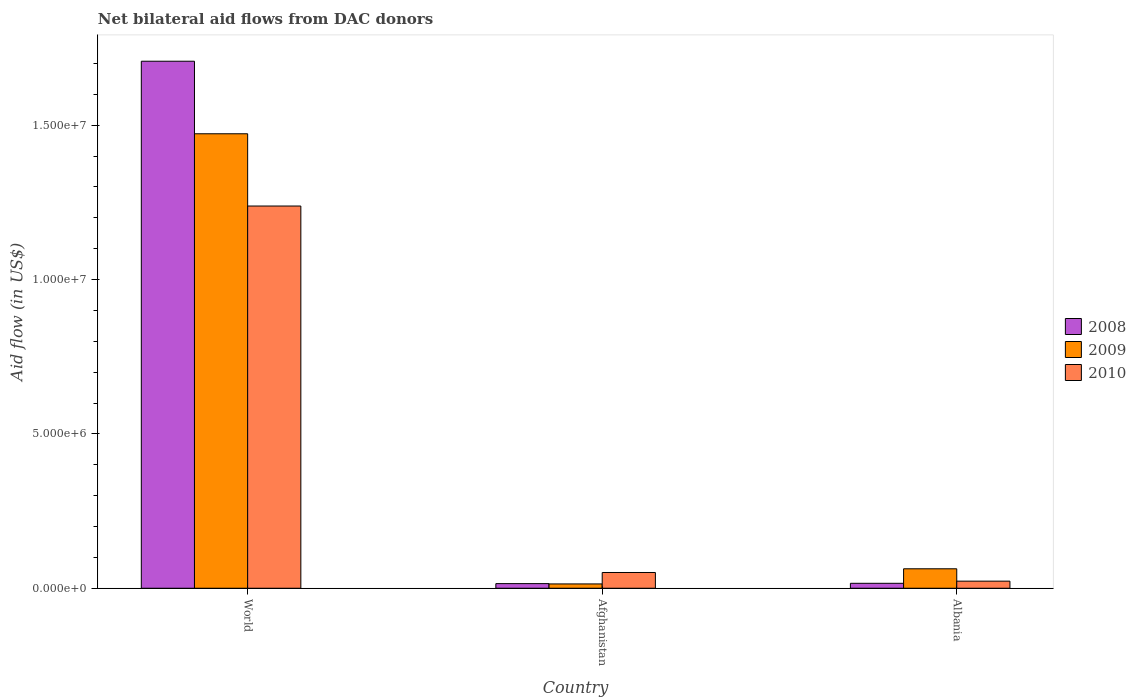How many groups of bars are there?
Ensure brevity in your answer.  3. How many bars are there on the 1st tick from the left?
Make the answer very short. 3. What is the label of the 3rd group of bars from the left?
Make the answer very short. Albania. What is the net bilateral aid flow in 2009 in World?
Provide a succinct answer. 1.47e+07. Across all countries, what is the maximum net bilateral aid flow in 2009?
Provide a short and direct response. 1.47e+07. In which country was the net bilateral aid flow in 2010 minimum?
Make the answer very short. Albania. What is the total net bilateral aid flow in 2009 in the graph?
Your answer should be very brief. 1.55e+07. What is the difference between the net bilateral aid flow in 2009 in Afghanistan and that in World?
Provide a succinct answer. -1.46e+07. What is the difference between the net bilateral aid flow in 2010 in World and the net bilateral aid flow in 2008 in Afghanistan?
Your answer should be compact. 1.22e+07. What is the average net bilateral aid flow in 2009 per country?
Provide a succinct answer. 5.16e+06. What is the difference between the net bilateral aid flow of/in 2009 and net bilateral aid flow of/in 2010 in Afghanistan?
Offer a terse response. -3.70e+05. What is the ratio of the net bilateral aid flow in 2009 in Albania to that in World?
Give a very brief answer. 0.04. What is the difference between the highest and the second highest net bilateral aid flow in 2008?
Your answer should be very brief. 1.69e+07. What is the difference between the highest and the lowest net bilateral aid flow in 2010?
Your answer should be very brief. 1.22e+07. In how many countries, is the net bilateral aid flow in 2010 greater than the average net bilateral aid flow in 2010 taken over all countries?
Your response must be concise. 1. Is the sum of the net bilateral aid flow in 2010 in Afghanistan and World greater than the maximum net bilateral aid flow in 2008 across all countries?
Give a very brief answer. No. What does the 2nd bar from the left in Afghanistan represents?
Ensure brevity in your answer.  2009. How many bars are there?
Ensure brevity in your answer.  9. How many countries are there in the graph?
Keep it short and to the point. 3. What is the difference between two consecutive major ticks on the Y-axis?
Provide a succinct answer. 5.00e+06. Does the graph contain grids?
Ensure brevity in your answer.  No. Where does the legend appear in the graph?
Your answer should be compact. Center right. What is the title of the graph?
Provide a succinct answer. Net bilateral aid flows from DAC donors. What is the label or title of the X-axis?
Provide a succinct answer. Country. What is the label or title of the Y-axis?
Give a very brief answer. Aid flow (in US$). What is the Aid flow (in US$) of 2008 in World?
Make the answer very short. 1.71e+07. What is the Aid flow (in US$) in 2009 in World?
Offer a terse response. 1.47e+07. What is the Aid flow (in US$) in 2010 in World?
Offer a terse response. 1.24e+07. What is the Aid flow (in US$) in 2009 in Afghanistan?
Make the answer very short. 1.40e+05. What is the Aid flow (in US$) of 2010 in Afghanistan?
Your response must be concise. 5.10e+05. What is the Aid flow (in US$) in 2009 in Albania?
Offer a terse response. 6.30e+05. Across all countries, what is the maximum Aid flow (in US$) of 2008?
Keep it short and to the point. 1.71e+07. Across all countries, what is the maximum Aid flow (in US$) in 2009?
Your response must be concise. 1.47e+07. Across all countries, what is the maximum Aid flow (in US$) of 2010?
Offer a very short reply. 1.24e+07. Across all countries, what is the minimum Aid flow (in US$) of 2009?
Offer a terse response. 1.40e+05. What is the total Aid flow (in US$) of 2008 in the graph?
Keep it short and to the point. 1.74e+07. What is the total Aid flow (in US$) in 2009 in the graph?
Keep it short and to the point. 1.55e+07. What is the total Aid flow (in US$) in 2010 in the graph?
Provide a succinct answer. 1.31e+07. What is the difference between the Aid flow (in US$) in 2008 in World and that in Afghanistan?
Your answer should be compact. 1.69e+07. What is the difference between the Aid flow (in US$) of 2009 in World and that in Afghanistan?
Provide a short and direct response. 1.46e+07. What is the difference between the Aid flow (in US$) in 2010 in World and that in Afghanistan?
Keep it short and to the point. 1.19e+07. What is the difference between the Aid flow (in US$) in 2008 in World and that in Albania?
Ensure brevity in your answer.  1.69e+07. What is the difference between the Aid flow (in US$) of 2009 in World and that in Albania?
Give a very brief answer. 1.41e+07. What is the difference between the Aid flow (in US$) of 2010 in World and that in Albania?
Offer a terse response. 1.22e+07. What is the difference between the Aid flow (in US$) in 2009 in Afghanistan and that in Albania?
Your answer should be very brief. -4.90e+05. What is the difference between the Aid flow (in US$) in 2010 in Afghanistan and that in Albania?
Your answer should be compact. 2.80e+05. What is the difference between the Aid flow (in US$) in 2008 in World and the Aid flow (in US$) in 2009 in Afghanistan?
Your answer should be very brief. 1.69e+07. What is the difference between the Aid flow (in US$) in 2008 in World and the Aid flow (in US$) in 2010 in Afghanistan?
Your response must be concise. 1.66e+07. What is the difference between the Aid flow (in US$) in 2009 in World and the Aid flow (in US$) in 2010 in Afghanistan?
Provide a succinct answer. 1.42e+07. What is the difference between the Aid flow (in US$) of 2008 in World and the Aid flow (in US$) of 2009 in Albania?
Offer a very short reply. 1.64e+07. What is the difference between the Aid flow (in US$) of 2008 in World and the Aid flow (in US$) of 2010 in Albania?
Your response must be concise. 1.68e+07. What is the difference between the Aid flow (in US$) in 2009 in World and the Aid flow (in US$) in 2010 in Albania?
Offer a terse response. 1.45e+07. What is the difference between the Aid flow (in US$) in 2008 in Afghanistan and the Aid flow (in US$) in 2009 in Albania?
Provide a succinct answer. -4.80e+05. What is the difference between the Aid flow (in US$) of 2008 in Afghanistan and the Aid flow (in US$) of 2010 in Albania?
Provide a short and direct response. -8.00e+04. What is the average Aid flow (in US$) of 2008 per country?
Offer a terse response. 5.79e+06. What is the average Aid flow (in US$) of 2009 per country?
Provide a succinct answer. 5.16e+06. What is the average Aid flow (in US$) in 2010 per country?
Keep it short and to the point. 4.37e+06. What is the difference between the Aid flow (in US$) in 2008 and Aid flow (in US$) in 2009 in World?
Offer a very short reply. 2.35e+06. What is the difference between the Aid flow (in US$) in 2008 and Aid flow (in US$) in 2010 in World?
Provide a succinct answer. 4.69e+06. What is the difference between the Aid flow (in US$) in 2009 and Aid flow (in US$) in 2010 in World?
Provide a short and direct response. 2.34e+06. What is the difference between the Aid flow (in US$) of 2008 and Aid flow (in US$) of 2009 in Afghanistan?
Provide a short and direct response. 10000. What is the difference between the Aid flow (in US$) of 2008 and Aid flow (in US$) of 2010 in Afghanistan?
Provide a short and direct response. -3.60e+05. What is the difference between the Aid flow (in US$) in 2009 and Aid flow (in US$) in 2010 in Afghanistan?
Make the answer very short. -3.70e+05. What is the difference between the Aid flow (in US$) of 2008 and Aid flow (in US$) of 2009 in Albania?
Your answer should be very brief. -4.70e+05. What is the difference between the Aid flow (in US$) in 2008 and Aid flow (in US$) in 2010 in Albania?
Your answer should be compact. -7.00e+04. What is the ratio of the Aid flow (in US$) of 2008 in World to that in Afghanistan?
Provide a short and direct response. 113.8. What is the ratio of the Aid flow (in US$) in 2009 in World to that in Afghanistan?
Your response must be concise. 105.14. What is the ratio of the Aid flow (in US$) of 2010 in World to that in Afghanistan?
Keep it short and to the point. 24.27. What is the ratio of the Aid flow (in US$) in 2008 in World to that in Albania?
Provide a succinct answer. 106.69. What is the ratio of the Aid flow (in US$) of 2009 in World to that in Albania?
Ensure brevity in your answer.  23.37. What is the ratio of the Aid flow (in US$) of 2010 in World to that in Albania?
Offer a terse response. 53.83. What is the ratio of the Aid flow (in US$) in 2009 in Afghanistan to that in Albania?
Keep it short and to the point. 0.22. What is the ratio of the Aid flow (in US$) of 2010 in Afghanistan to that in Albania?
Your response must be concise. 2.22. What is the difference between the highest and the second highest Aid flow (in US$) in 2008?
Give a very brief answer. 1.69e+07. What is the difference between the highest and the second highest Aid flow (in US$) of 2009?
Make the answer very short. 1.41e+07. What is the difference between the highest and the second highest Aid flow (in US$) in 2010?
Provide a succinct answer. 1.19e+07. What is the difference between the highest and the lowest Aid flow (in US$) of 2008?
Offer a terse response. 1.69e+07. What is the difference between the highest and the lowest Aid flow (in US$) in 2009?
Your answer should be compact. 1.46e+07. What is the difference between the highest and the lowest Aid flow (in US$) in 2010?
Make the answer very short. 1.22e+07. 